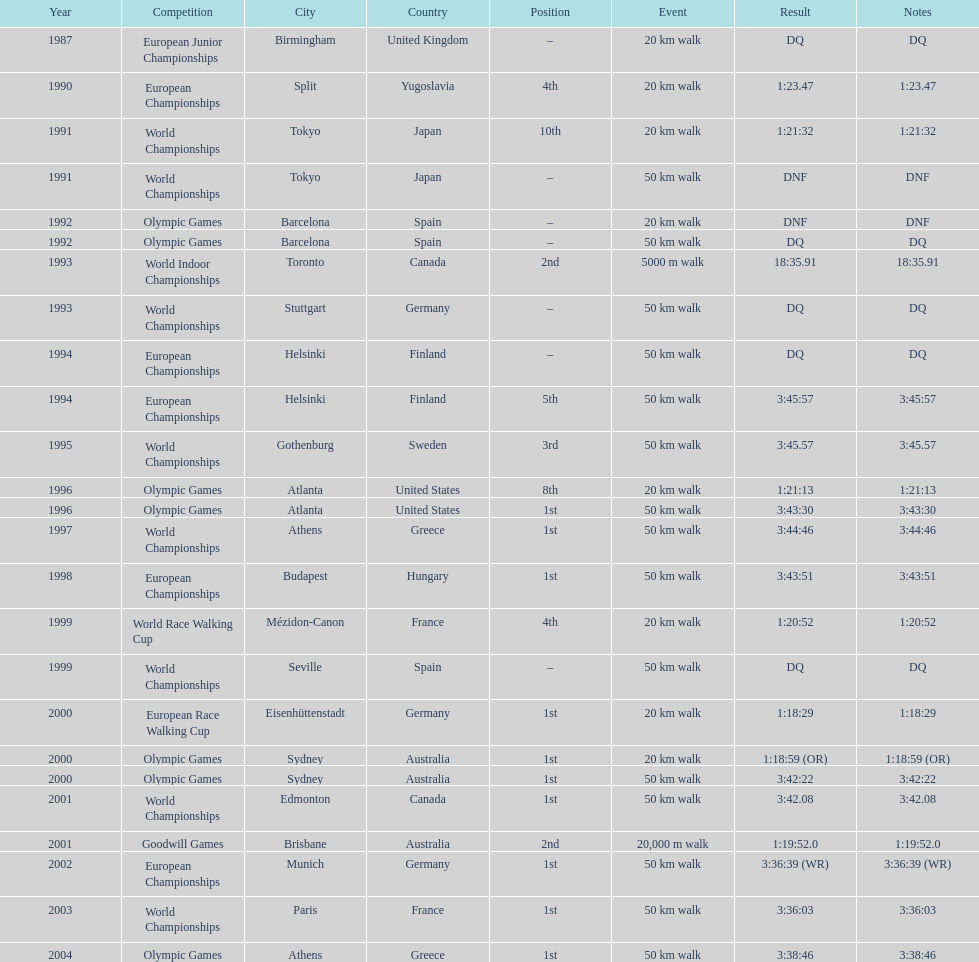How long did it take to walk 50 km in the 2004 olympic games? 3:38:46. 